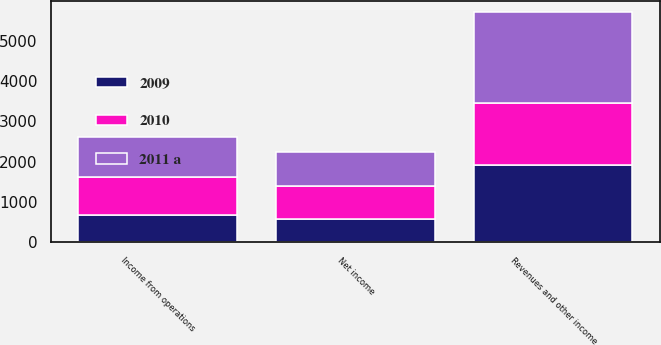Convert chart. <chart><loc_0><loc_0><loc_500><loc_500><stacked_bar_chart><ecel><fcel>Revenues and other income<fcel>Income from operations<fcel>Net income<nl><fcel>2010<fcel>1544<fcel>942<fcel>820<nl><fcel>2011 a<fcel>2243<fcel>999<fcel>841<nl><fcel>2009<fcel>1916<fcel>677<fcel>576<nl></chart> 